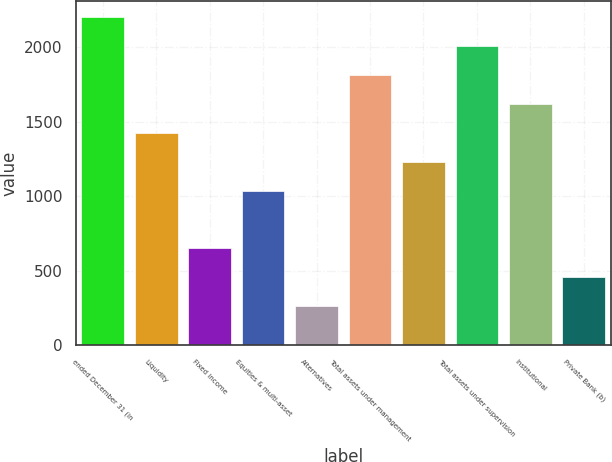<chart> <loc_0><loc_0><loc_500><loc_500><bar_chart><fcel>ended December 31 (in<fcel>Liquidity<fcel>Fixed income<fcel>Equities & multi-asset<fcel>Alternatives<fcel>Total assets under management<fcel>Unnamed: 6<fcel>Total assets under supervision<fcel>Institutional<fcel>Private Bank (b)<nl><fcel>2203<fcel>1427<fcel>651<fcel>1039<fcel>263<fcel>1815<fcel>1233<fcel>2009<fcel>1621<fcel>457<nl></chart> 